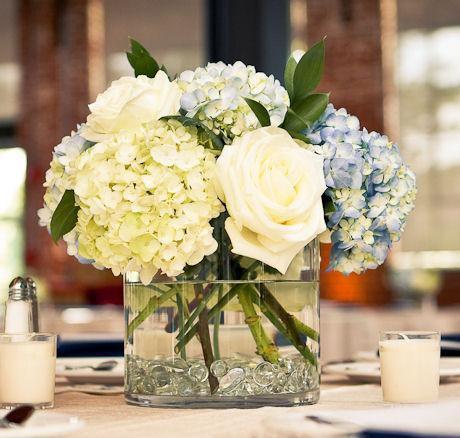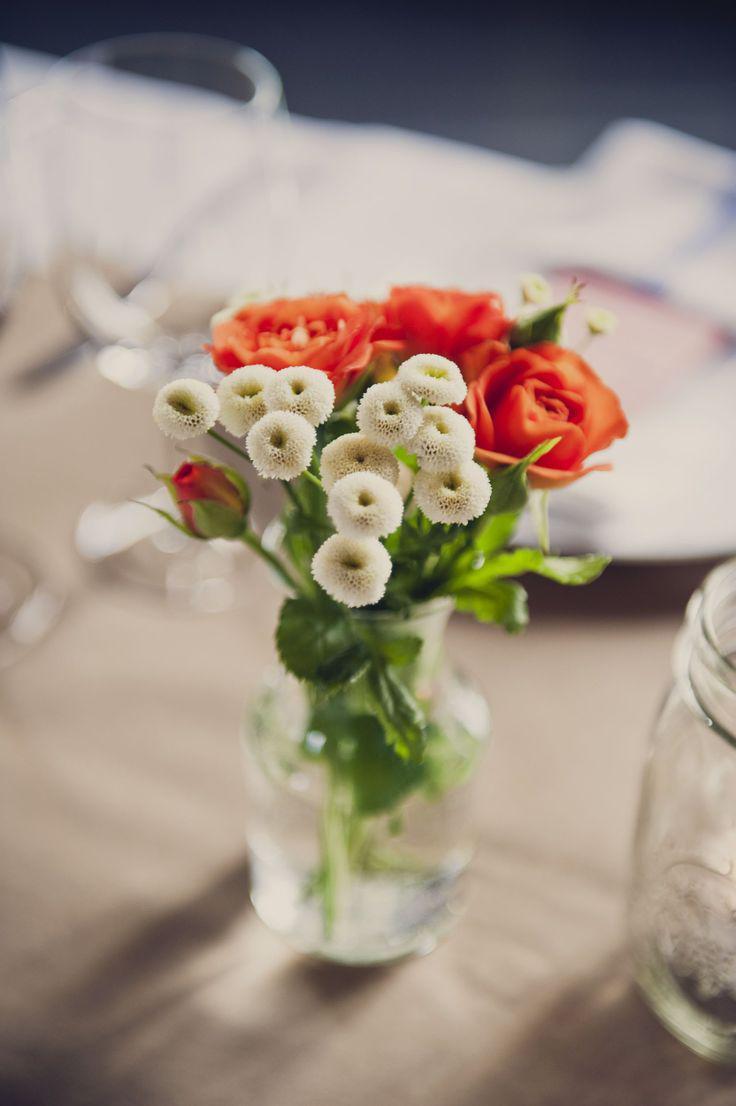The first image is the image on the left, the second image is the image on the right. Considering the images on both sides, is "There are 3 non-clear vases." valid? Answer yes or no. No. 